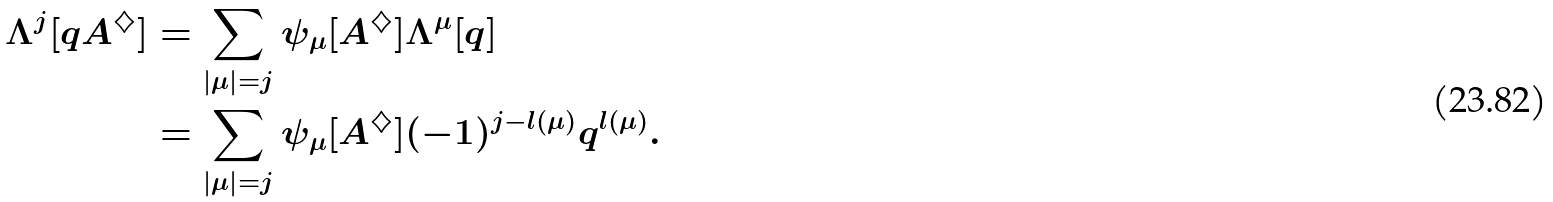Convert formula to latex. <formula><loc_0><loc_0><loc_500><loc_500>\Lambda ^ { j } [ q A ^ { \diamondsuit } ] & = \sum _ { \left | { \mu } \right | = j } \psi _ { \mu } [ A ^ { \diamondsuit } ] \Lambda ^ { \mu } [ q ] \\ & = \sum _ { \left | { \mu } \right | = j } \psi _ { \mu } [ A ^ { \diamondsuit } ] ( - 1 ) ^ { j - l ( \mu ) } q ^ { l ( \mu ) } .</formula> 